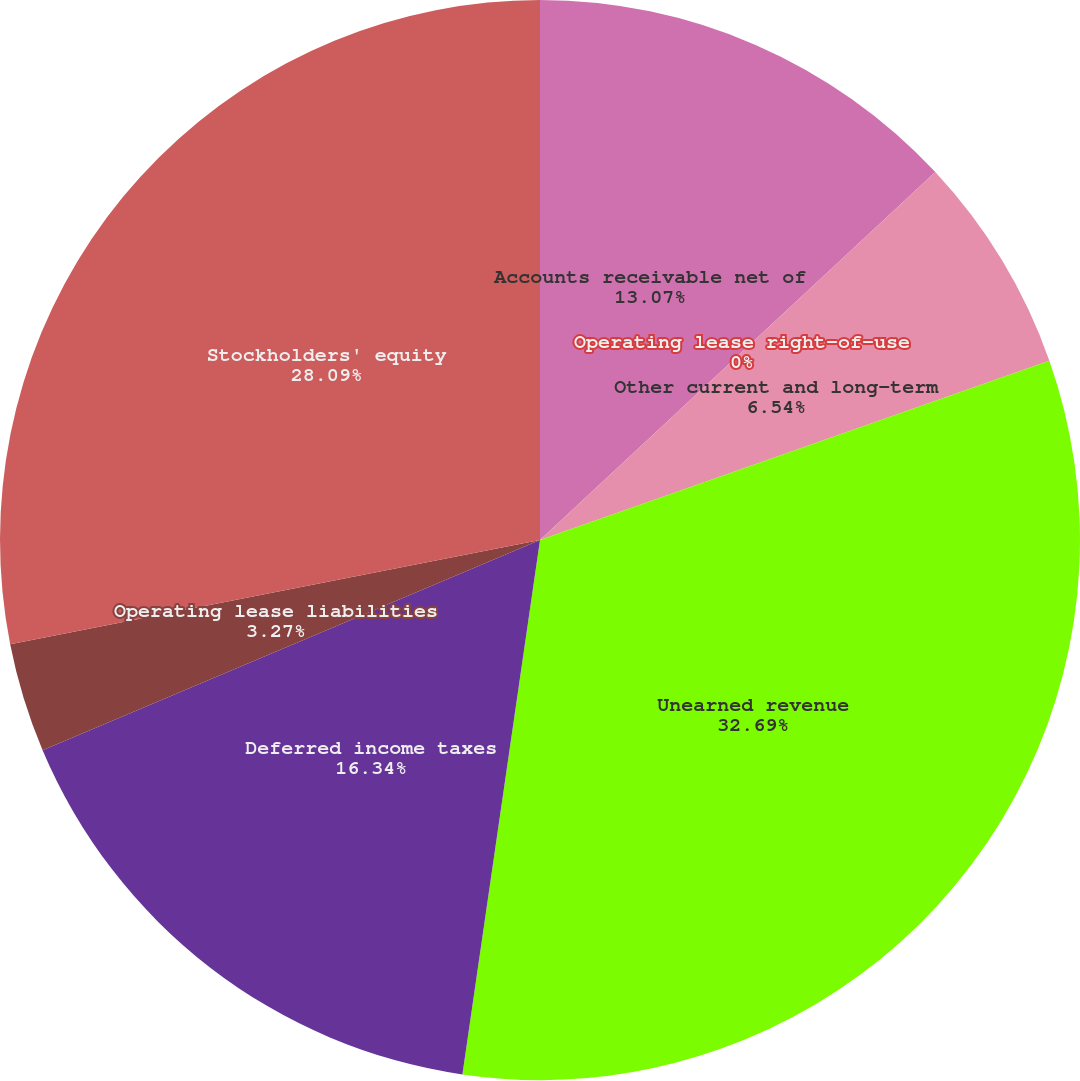Convert chart. <chart><loc_0><loc_0><loc_500><loc_500><pie_chart><fcel>Accounts receivable net of<fcel>Operating lease right-of-use<fcel>Other current and long-term<fcel>Unearned revenue<fcel>Deferred income taxes<fcel>Operating lease liabilities<fcel>Stockholders' equity<nl><fcel>13.07%<fcel>0.0%<fcel>6.54%<fcel>32.68%<fcel>16.34%<fcel>3.27%<fcel>28.09%<nl></chart> 